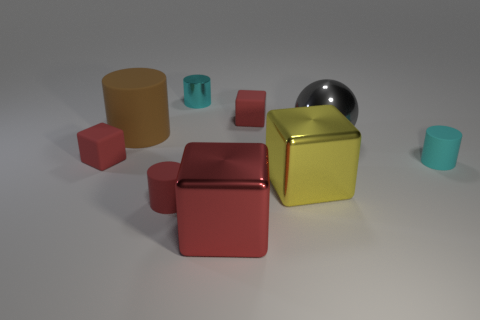Subtract all brown cylinders. How many red cubes are left? 3 Subtract 1 cylinders. How many cylinders are left? 3 Subtract all cylinders. How many objects are left? 5 Subtract all yellow things. Subtract all tiny blue cylinders. How many objects are left? 8 Add 4 tiny shiny cylinders. How many tiny shiny cylinders are left? 5 Add 2 big gray shiny objects. How many big gray shiny objects exist? 3 Subtract 0 blue spheres. How many objects are left? 9 